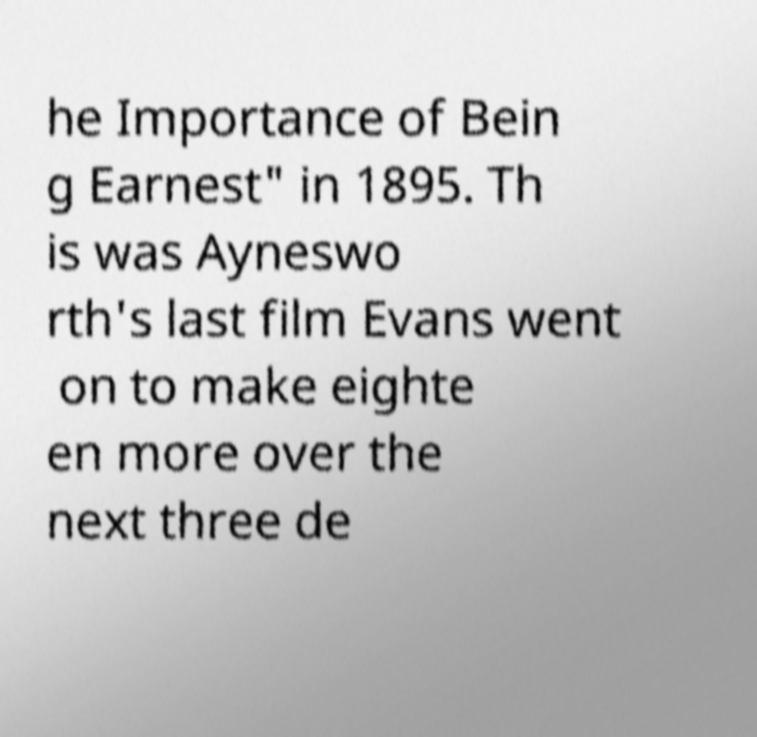For documentation purposes, I need the text within this image transcribed. Could you provide that? he Importance of Bein g Earnest" in 1895. Th is was Ayneswo rth's last film Evans went on to make eighte en more over the next three de 